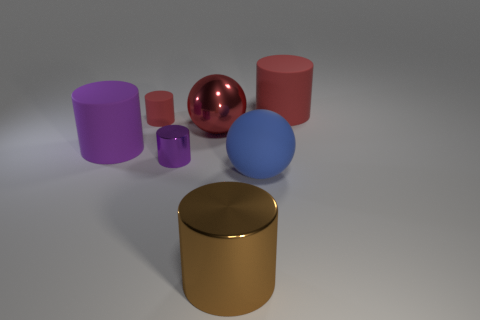Subtract all purple rubber cylinders. How many cylinders are left? 4 Subtract all brown cylinders. How many cylinders are left? 4 Subtract all green cylinders. Subtract all green blocks. How many cylinders are left? 5 Add 2 small gray matte balls. How many objects exist? 9 Subtract all balls. How many objects are left? 5 Add 1 tiny red rubber cylinders. How many tiny red rubber cylinders are left? 2 Add 2 small gray blocks. How many small gray blocks exist? 2 Subtract 0 yellow cylinders. How many objects are left? 7 Subtract all tiny blue blocks. Subtract all large red metallic balls. How many objects are left? 6 